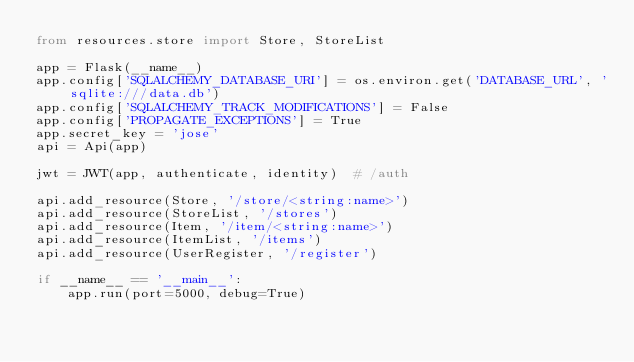Convert code to text. <code><loc_0><loc_0><loc_500><loc_500><_Python_>from resources.store import Store, StoreList

app = Flask(__name__)
app.config['SQLALCHEMY_DATABASE_URI'] = os.environ.get('DATABASE_URL', 'sqlite:///data.db')
app.config['SQLALCHEMY_TRACK_MODIFICATIONS'] = False
app.config['PROPAGATE_EXCEPTIONS'] = True
app.secret_key = 'jose'
api = Api(app)

jwt = JWT(app, authenticate, identity)  # /auth

api.add_resource(Store, '/store/<string:name>')
api.add_resource(StoreList, '/stores')
api.add_resource(Item, '/item/<string:name>')
api.add_resource(ItemList, '/items')
api.add_resource(UserRegister, '/register')

if __name__ == '__main__':
    app.run(port=5000, debug=True)</code> 